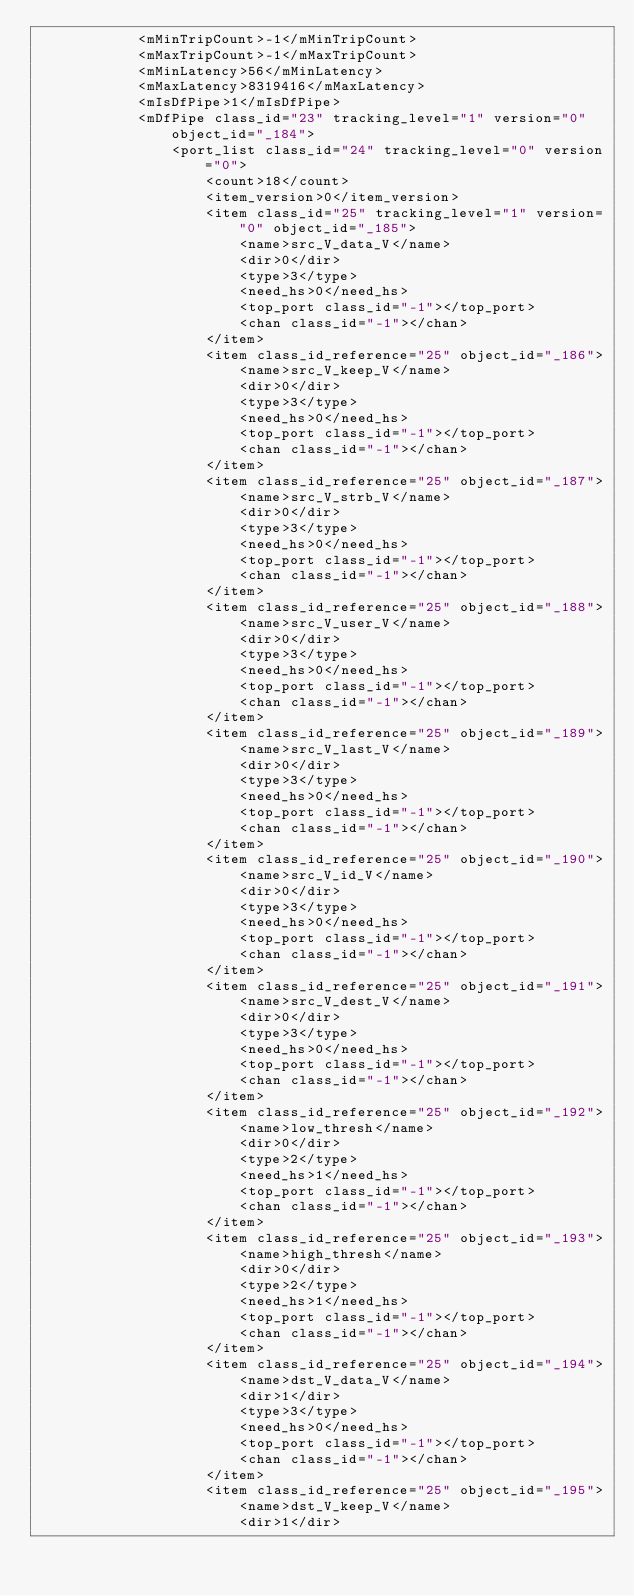<code> <loc_0><loc_0><loc_500><loc_500><_Ada_>			<mMinTripCount>-1</mMinTripCount>
			<mMaxTripCount>-1</mMaxTripCount>
			<mMinLatency>56</mMinLatency>
			<mMaxLatency>8319416</mMaxLatency>
			<mIsDfPipe>1</mIsDfPipe>
			<mDfPipe class_id="23" tracking_level="1" version="0" object_id="_184">
				<port_list class_id="24" tracking_level="0" version="0">
					<count>18</count>
					<item_version>0</item_version>
					<item class_id="25" tracking_level="1" version="0" object_id="_185">
						<name>src_V_data_V</name>
						<dir>0</dir>
						<type>3</type>
						<need_hs>0</need_hs>
						<top_port class_id="-1"></top_port>
						<chan class_id="-1"></chan>
					</item>
					<item class_id_reference="25" object_id="_186">
						<name>src_V_keep_V</name>
						<dir>0</dir>
						<type>3</type>
						<need_hs>0</need_hs>
						<top_port class_id="-1"></top_port>
						<chan class_id="-1"></chan>
					</item>
					<item class_id_reference="25" object_id="_187">
						<name>src_V_strb_V</name>
						<dir>0</dir>
						<type>3</type>
						<need_hs>0</need_hs>
						<top_port class_id="-1"></top_port>
						<chan class_id="-1"></chan>
					</item>
					<item class_id_reference="25" object_id="_188">
						<name>src_V_user_V</name>
						<dir>0</dir>
						<type>3</type>
						<need_hs>0</need_hs>
						<top_port class_id="-1"></top_port>
						<chan class_id="-1"></chan>
					</item>
					<item class_id_reference="25" object_id="_189">
						<name>src_V_last_V</name>
						<dir>0</dir>
						<type>3</type>
						<need_hs>0</need_hs>
						<top_port class_id="-1"></top_port>
						<chan class_id="-1"></chan>
					</item>
					<item class_id_reference="25" object_id="_190">
						<name>src_V_id_V</name>
						<dir>0</dir>
						<type>3</type>
						<need_hs>0</need_hs>
						<top_port class_id="-1"></top_port>
						<chan class_id="-1"></chan>
					</item>
					<item class_id_reference="25" object_id="_191">
						<name>src_V_dest_V</name>
						<dir>0</dir>
						<type>3</type>
						<need_hs>0</need_hs>
						<top_port class_id="-1"></top_port>
						<chan class_id="-1"></chan>
					</item>
					<item class_id_reference="25" object_id="_192">
						<name>low_thresh</name>
						<dir>0</dir>
						<type>2</type>
						<need_hs>1</need_hs>
						<top_port class_id="-1"></top_port>
						<chan class_id="-1"></chan>
					</item>
					<item class_id_reference="25" object_id="_193">
						<name>high_thresh</name>
						<dir>0</dir>
						<type>2</type>
						<need_hs>1</need_hs>
						<top_port class_id="-1"></top_port>
						<chan class_id="-1"></chan>
					</item>
					<item class_id_reference="25" object_id="_194">
						<name>dst_V_data_V</name>
						<dir>1</dir>
						<type>3</type>
						<need_hs>0</need_hs>
						<top_port class_id="-1"></top_port>
						<chan class_id="-1"></chan>
					</item>
					<item class_id_reference="25" object_id="_195">
						<name>dst_V_keep_V</name>
						<dir>1</dir></code> 